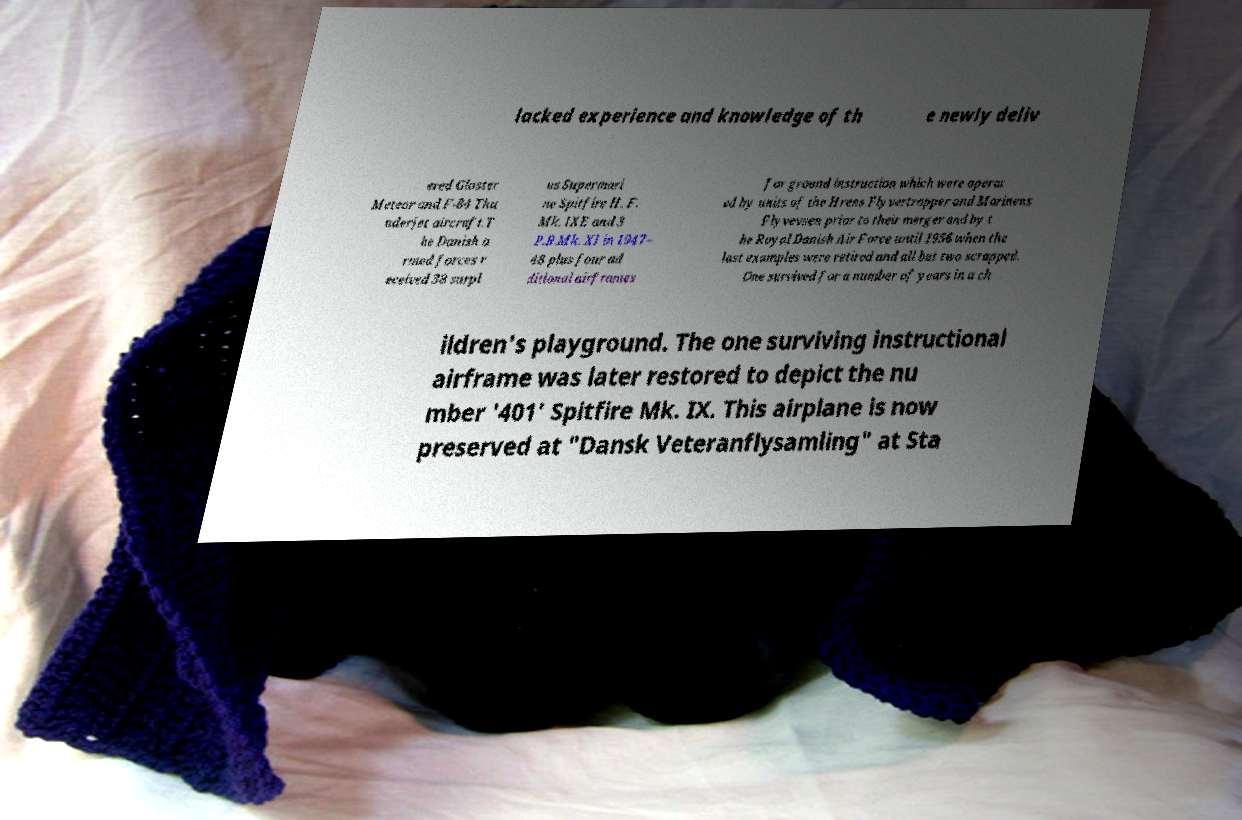Could you extract and type out the text from this image? lacked experience and knowledge of th e newly deliv ered Gloster Meteor and F-84 Thu nderjet aircraft.T he Danish a rmed forces r eceived 38 surpl us Supermari ne Spitfire H. F. Mk. IXE and 3 P.R.Mk. XI in 1947– 48 plus four ad ditional airframes for ground instruction which were operat ed by units of the Hrens Flyvertropper and Marinens Flyvevsen prior to their merger and by t he Royal Danish Air Force until 1956 when the last examples were retired and all but two scrapped. One survived for a number of years in a ch ildren's playground. The one surviving instructional airframe was later restored to depict the nu mber '401' Spitfire Mk. IX. This airplane is now preserved at "Dansk Veteranflysamling" at Sta 